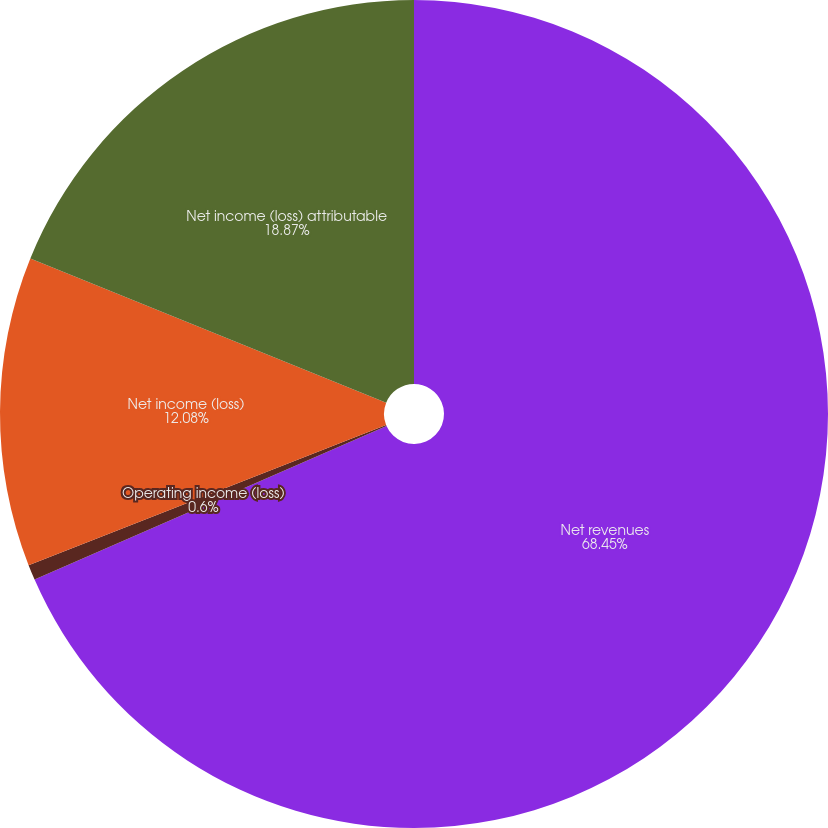Convert chart to OTSL. <chart><loc_0><loc_0><loc_500><loc_500><pie_chart><fcel>Net revenues<fcel>Operating income (loss)<fcel>Net income (loss)<fcel>Net income (loss) attributable<nl><fcel>68.45%<fcel>0.6%<fcel>12.08%<fcel>18.87%<nl></chart> 